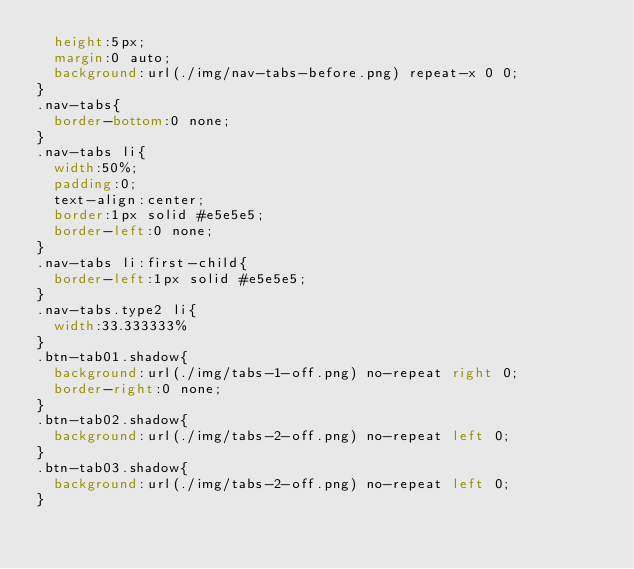Convert code to text. <code><loc_0><loc_0><loc_500><loc_500><_CSS_>  height:5px;
  margin:0 auto;
  background:url(./img/nav-tabs-before.png) repeat-x 0 0;
}
.nav-tabs{
  border-bottom:0 none;
}
.nav-tabs li{
  width:50%;
  padding:0;
  text-align:center;
  border:1px solid #e5e5e5;
  border-left:0 none;
}
.nav-tabs li:first-child{
  border-left:1px solid #e5e5e5;
}
.nav-tabs.type2 li{
  width:33.333333%
}
.btn-tab01.shadow{
  background:url(./img/tabs-1-off.png) no-repeat right 0;
  border-right:0 none;
}
.btn-tab02.shadow{
  background:url(./img/tabs-2-off.png) no-repeat left 0;
}
.btn-tab03.shadow{
  background:url(./img/tabs-2-off.png) no-repeat left 0;
}</code> 